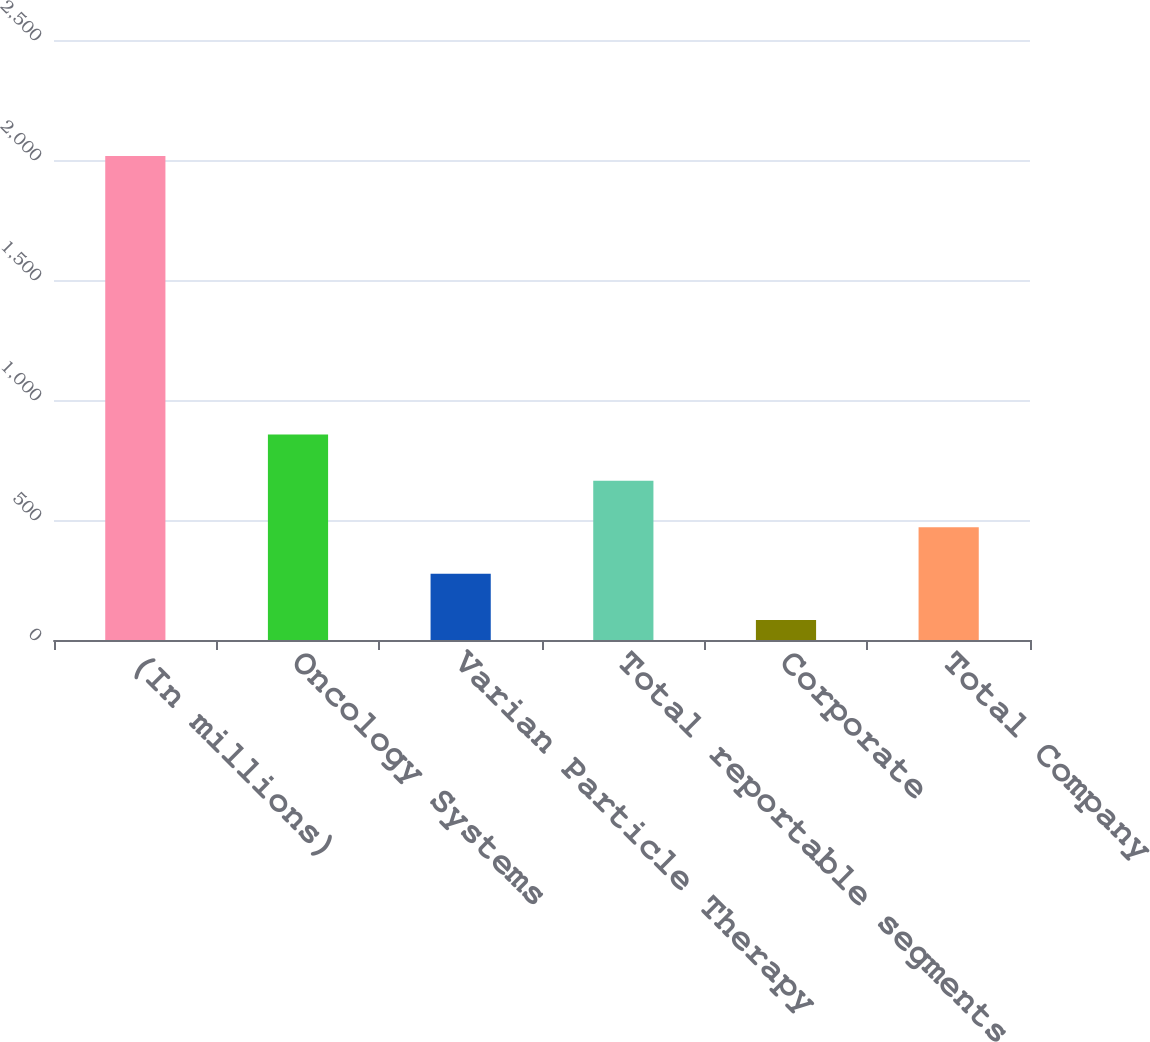<chart> <loc_0><loc_0><loc_500><loc_500><bar_chart><fcel>(In millions)<fcel>Oncology Systems<fcel>Varian Particle Therapy<fcel>Total reportable segments<fcel>Corporate<fcel>Total Company<nl><fcel>2017<fcel>856.66<fcel>276.49<fcel>663.27<fcel>83.1<fcel>469.88<nl></chart> 